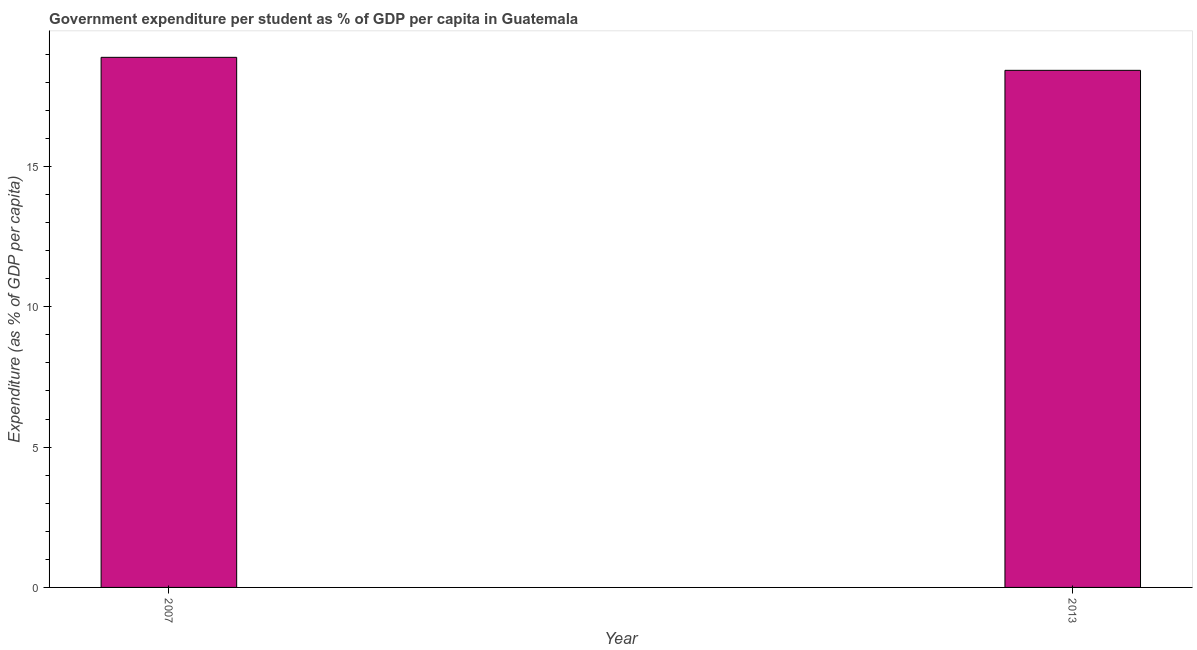What is the title of the graph?
Offer a terse response. Government expenditure per student as % of GDP per capita in Guatemala. What is the label or title of the Y-axis?
Your answer should be very brief. Expenditure (as % of GDP per capita). What is the government expenditure per student in 2007?
Offer a terse response. 18.89. Across all years, what is the maximum government expenditure per student?
Your answer should be compact. 18.89. Across all years, what is the minimum government expenditure per student?
Your response must be concise. 18.43. In which year was the government expenditure per student maximum?
Provide a short and direct response. 2007. In which year was the government expenditure per student minimum?
Give a very brief answer. 2013. What is the sum of the government expenditure per student?
Ensure brevity in your answer.  37.31. What is the difference between the government expenditure per student in 2007 and 2013?
Keep it short and to the point. 0.46. What is the average government expenditure per student per year?
Your answer should be very brief. 18.66. What is the median government expenditure per student?
Offer a very short reply. 18.66. Do a majority of the years between 2007 and 2013 (inclusive) have government expenditure per student greater than 3 %?
Make the answer very short. Yes. Is the government expenditure per student in 2007 less than that in 2013?
Your response must be concise. No. In how many years, is the government expenditure per student greater than the average government expenditure per student taken over all years?
Provide a short and direct response. 1. Are all the bars in the graph horizontal?
Your answer should be compact. No. What is the difference between two consecutive major ticks on the Y-axis?
Your answer should be very brief. 5. What is the Expenditure (as % of GDP per capita) of 2007?
Provide a short and direct response. 18.89. What is the Expenditure (as % of GDP per capita) of 2013?
Your answer should be compact. 18.43. What is the difference between the Expenditure (as % of GDP per capita) in 2007 and 2013?
Provide a succinct answer. 0.46. 